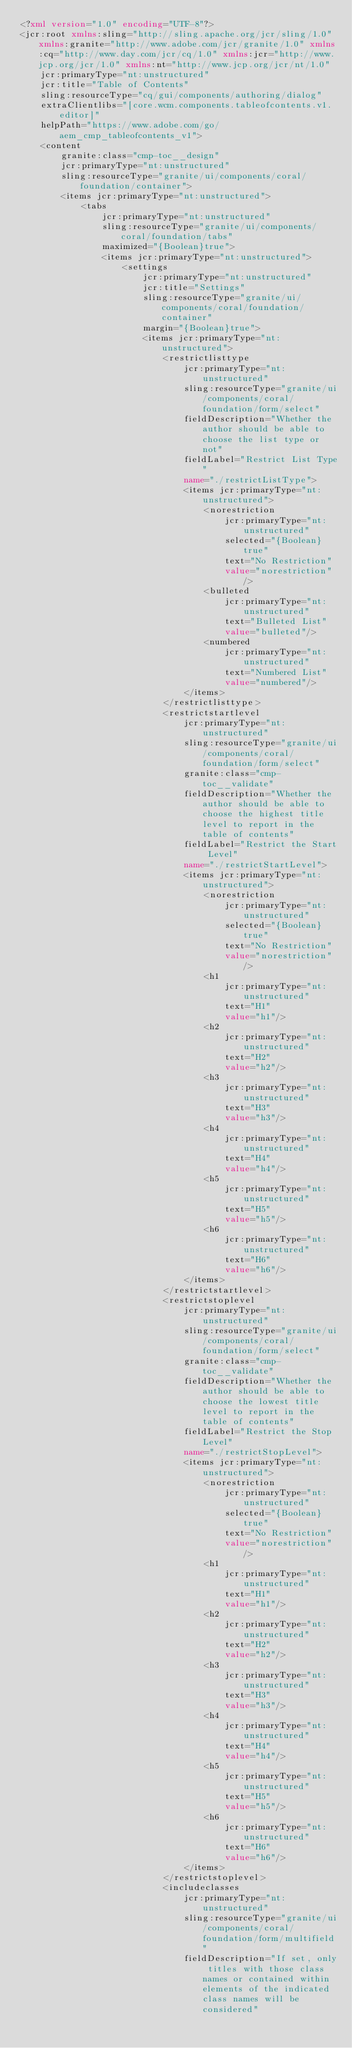Convert code to text. <code><loc_0><loc_0><loc_500><loc_500><_XML_><?xml version="1.0" encoding="UTF-8"?>
<jcr:root xmlns:sling="http://sling.apache.org/jcr/sling/1.0" xmlns:granite="http://www.adobe.com/jcr/granite/1.0" xmlns:cq="http://www.day.com/jcr/cq/1.0" xmlns:jcr="http://www.jcp.org/jcr/1.0" xmlns:nt="http://www.jcp.org/jcr/nt/1.0"
    jcr:primaryType="nt:unstructured"
    jcr:title="Table of Contents"
    sling:resourceType="cq/gui/components/authoring/dialog"
    extraClientlibs="[core.wcm.components.tableofcontents.v1.editor]"
    helpPath="https://www.adobe.com/go/aem_cmp_tableofcontents_v1">
    <content
        granite:class="cmp-toc__design"
        jcr:primaryType="nt:unstructured"
        sling:resourceType="granite/ui/components/coral/foundation/container">
        <items jcr:primaryType="nt:unstructured">
            <tabs
                jcr:primaryType="nt:unstructured"
                sling:resourceType="granite/ui/components/coral/foundation/tabs"
                maximized="{Boolean}true">
                <items jcr:primaryType="nt:unstructured">
                    <settings
                        jcr:primaryType="nt:unstructured"
                        jcr:title="Settings"
                        sling:resourceType="granite/ui/components/coral/foundation/container"
                        margin="{Boolean}true">
                        <items jcr:primaryType="nt:unstructured">
                            <restrictlisttype
                                jcr:primaryType="nt:unstructured"
                                sling:resourceType="granite/ui/components/coral/foundation/form/select"
                                fieldDescription="Whether the author should be able to choose the list type or not"
                                fieldLabel="Restrict List Type"
                                name="./restrictListType">
                                <items jcr:primaryType="nt:unstructured">
                                    <norestriction
                                        jcr:primaryType="nt:unstructured"
                                        selected="{Boolean}true"
                                        text="No Restriction"
                                        value="norestriction"/>
                                    <bulleted
                                        jcr:primaryType="nt:unstructured"
                                        text="Bulleted List"
                                        value="bulleted"/>
                                    <numbered
                                        jcr:primaryType="nt:unstructured"
                                        text="Numbered List"
                                        value="numbered"/>
                                </items>
                            </restrictlisttype>
                            <restrictstartlevel
                                jcr:primaryType="nt:unstructured"
                                sling:resourceType="granite/ui/components/coral/foundation/form/select"
                                granite:class="cmp-toc__validate"
                                fieldDescription="Whether the author should be able to choose the highest title level to report in the table of contents"
                                fieldLabel="Restrict the Start Level"
                                name="./restrictStartLevel">
                                <items jcr:primaryType="nt:unstructured">
                                    <norestriction
                                        jcr:primaryType="nt:unstructured"
                                        selected="{Boolean}true"
                                        text="No Restriction"
                                        value="norestriction"/>
                                    <h1
                                        jcr:primaryType="nt:unstructured"
                                        text="H1"
                                        value="h1"/>
                                    <h2
                                        jcr:primaryType="nt:unstructured"
                                        text="H2"
                                        value="h2"/>
                                    <h3
                                        jcr:primaryType="nt:unstructured"
                                        text="H3"
                                        value="h3"/>
                                    <h4
                                        jcr:primaryType="nt:unstructured"
                                        text="H4"
                                        value="h4"/>
                                    <h5
                                        jcr:primaryType="nt:unstructured"
                                        text="H5"
                                        value="h5"/>
                                    <h6
                                        jcr:primaryType="nt:unstructured"
                                        text="H6"
                                        value="h6"/>
                                </items>
                            </restrictstartlevel>
                            <restrictstoplevel
                                jcr:primaryType="nt:unstructured"
                                sling:resourceType="granite/ui/components/coral/foundation/form/select"
                                granite:class="cmp-toc__validate"
                                fieldDescription="Whether the author should be able to choose the lowest title level to report in the table of contents"
                                fieldLabel="Restrict the Stop Level"
                                name="./restrictStopLevel">
                                <items jcr:primaryType="nt:unstructured">
                                    <norestriction
                                        jcr:primaryType="nt:unstructured"
                                        selected="{Boolean}true"
                                        text="No Restriction"
                                        value="norestriction"/>
                                    <h1
                                        jcr:primaryType="nt:unstructured"
                                        text="H1"
                                        value="h1"/>
                                    <h2
                                        jcr:primaryType="nt:unstructured"
                                        text="H2"
                                        value="h2"/>
                                    <h3
                                        jcr:primaryType="nt:unstructured"
                                        text="H3"
                                        value="h3"/>
                                    <h4
                                        jcr:primaryType="nt:unstructured"
                                        text="H4"
                                        value="h4"/>
                                    <h5
                                        jcr:primaryType="nt:unstructured"
                                        text="H5"
                                        value="h5"/>
                                    <h6
                                        jcr:primaryType="nt:unstructured"
                                        text="H6"
                                        value="h6"/>
                                </items>
                            </restrictstoplevel>
                            <includeclasses
                                jcr:primaryType="nt:unstructured"
                                sling:resourceType="granite/ui/components/coral/foundation/form/multifield"
                                fieldDescription="If set, only titles with those class names or contained within elements of the indicated class names will be considered"</code> 